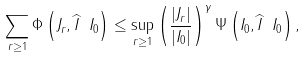Convert formula to latex. <formula><loc_0><loc_0><loc_500><loc_500>\sum _ { r \geq 1 } \Phi \left ( J _ { r } , \widehat { I } \ I _ { 0 } \right ) \leq \sup _ { r \geq 1 } \left ( \frac { \left | J _ { r } \right | } { \left | I _ { 0 } \right | } \right ) ^ { \gamma } \Psi \left ( I _ { 0 } , \widehat { I } \ I _ { 0 } \right ) ,</formula> 